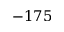Convert formula to latex. <formula><loc_0><loc_0><loc_500><loc_500>- 1 7 5</formula> 